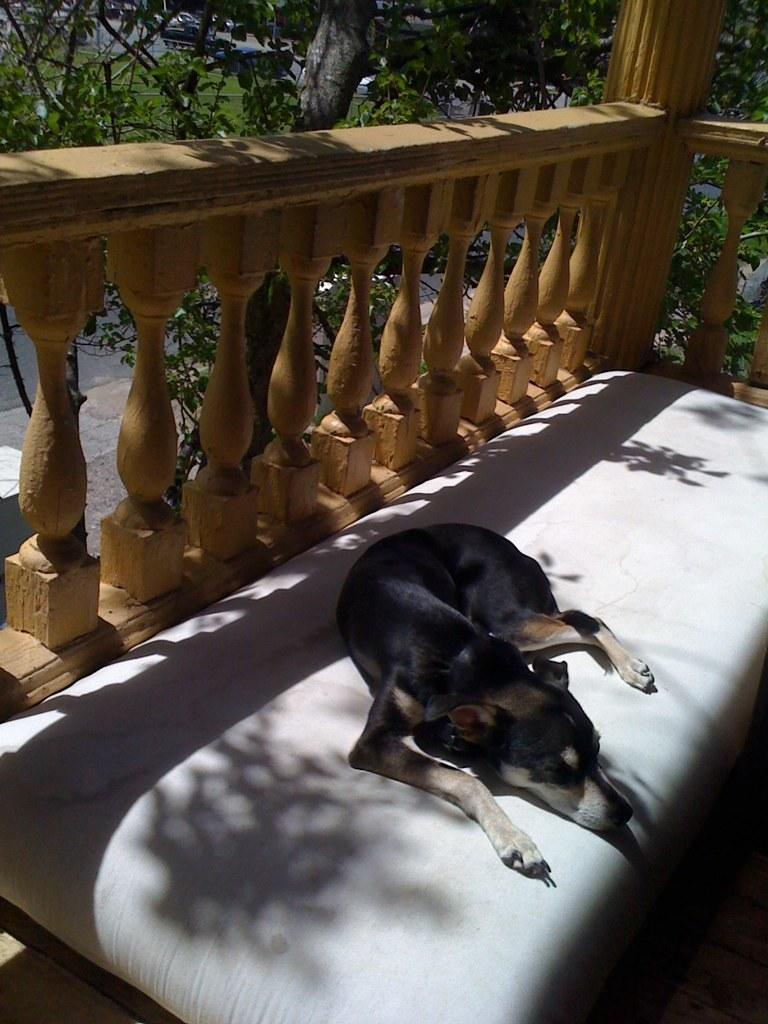What type of animal is present in the image? There is a dog in the image. What is the color of the dog? The dog is black in color. Where is the dog resting in the image? The dog is resting on a bed. What can be seen in the background of the image? There are trees in the background of the image. What type of structure is visible in the image? There is fencing in the image. Where is the kitten hiding in the image? There is no kitten present in the image. What type of animal might be found in a cave, and is it visible in the image? There is no mention of a cave or any animals associated with caves in the image. 